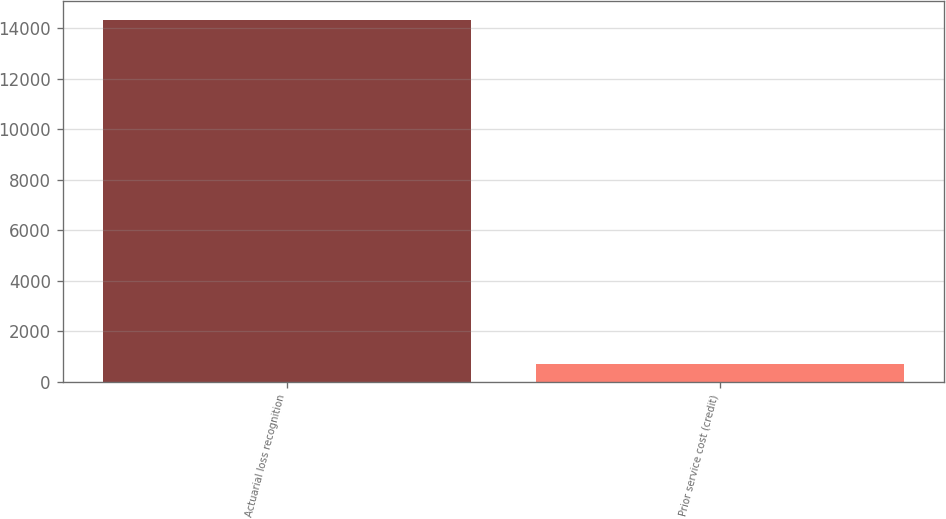Convert chart. <chart><loc_0><loc_0><loc_500><loc_500><bar_chart><fcel>Actuarial loss recognition<fcel>Prior service cost (credit)<nl><fcel>14344<fcel>696<nl></chart> 